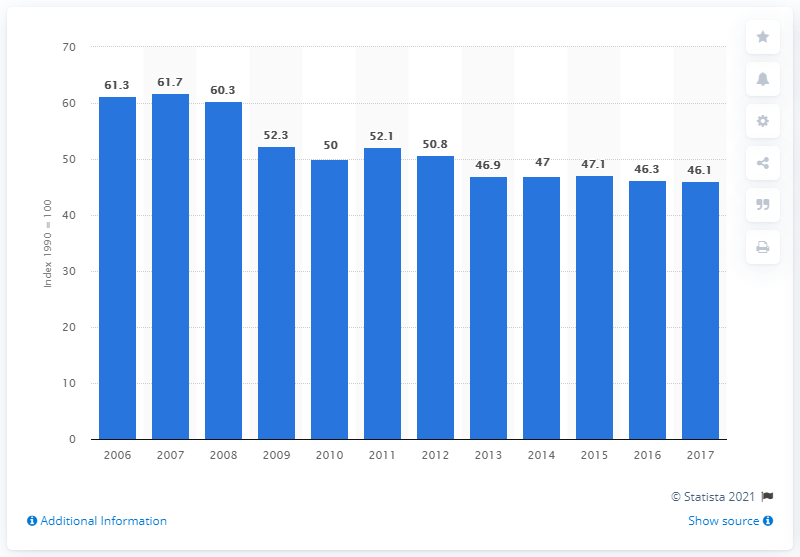Draw attention to some important aspects in this diagram. In 2017, the greenhouse gas emissions index in Romania was 46.1. 